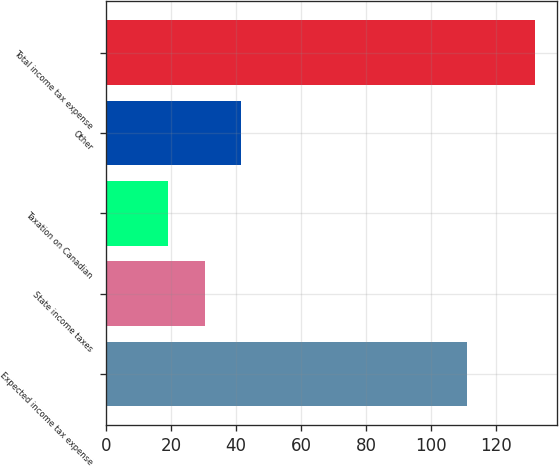<chart> <loc_0><loc_0><loc_500><loc_500><bar_chart><fcel>Expected income tax expense<fcel>State income taxes<fcel>Taxation on Canadian<fcel>Other<fcel>Total income tax expense<nl><fcel>111<fcel>30.3<fcel>19<fcel>41.6<fcel>132<nl></chart> 